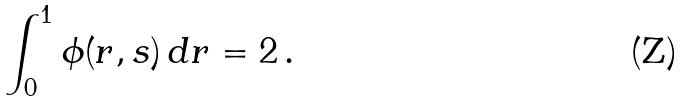<formula> <loc_0><loc_0><loc_500><loc_500>\int _ { 0 } ^ { 1 } \phi ( r , s ) \, d r = 2 \, .</formula> 